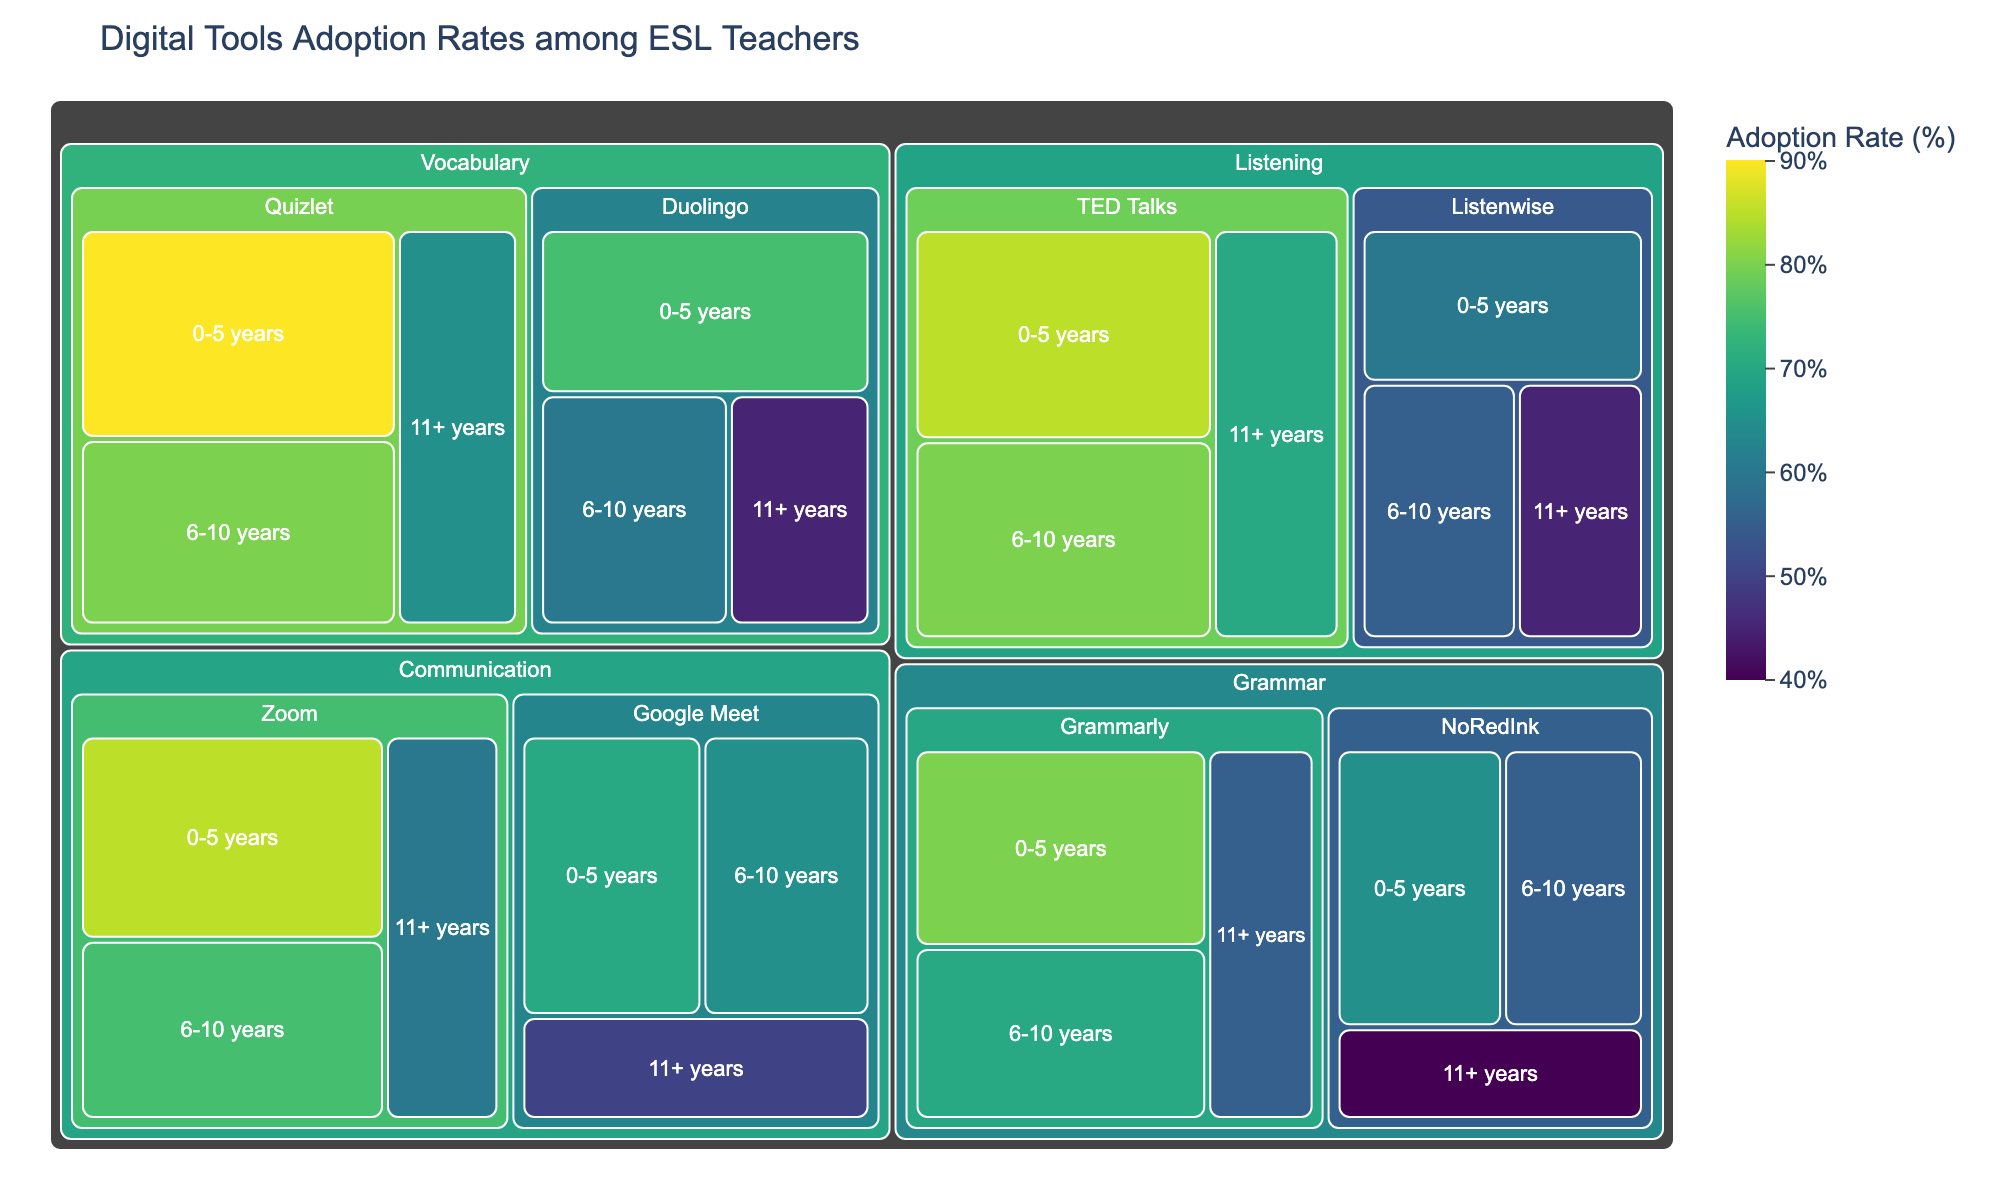What is the title of the Treemap plot? The title of a plot is often located at the top center of the plot, summarizing the main content. In this case, the title should tell us what we are looking at.
Answer: Digital Tools Adoption Rates among ESL Teachers Which tool has the highest adoption rate among ESL teachers with 0-5 years of experience? To identify the highest rate, look at the adoption rates of all tools for those with 0-5 years of experience. Compare and find the maximum value.
Answer: Quizlet What is the adoption rate for Google Meet among teachers with 11+ years of experience? Locate the segment for Google Meet under the Communication category and check the section for teachers with 11+ years of experience.
Answer: 50 Which category has the most tools listed? By counting the number of different tools under each category in the Treemap, we can identify the one with the highest count.
Answer: Communication Compare the adoption rates of Zoom and Google Meet among teachers with 6-10 years of experience. Which one is higher, and by how much? Find the sections for Zoom and Google Meet under the Communication category for teachers with 6-10 years of experience. Subtract the smaller rate from the larger one to find the difference.
Answer: Zoom is higher by 10 What is the average adoption rate for Grammarly across all experience levels? Add up the adoption rates for Grammarly across all experience levels and divide by the number of experience levels (3).
Answer: (80+70+55)/3 = 68.33 Among Vocabulary tools, which tool shows the largest decrease in adoption rate from 0-5 years to 11+ years of experience? Compare the difference between the adoption rates for each tool in the Vocabulary category across 0-5 years and 11+ years. Identify the tool with the largest reduction.
Answer: Duolingo How does the adoption rate of TED Talks compare between teachers with 0-5 years and 11+ years of experience? Find the adoption rates for TED Talks among these two groups, then compare the values to see the difference.
Answer: TED Talks is higher by 15 Which tool in the Grammar category has the lowest adoption rate among teachers with 11+ years of experience? Look at all tools in the Grammar category and identify the one with the lowest adoption rate for 11+ years.
Answer: NoRedInk 